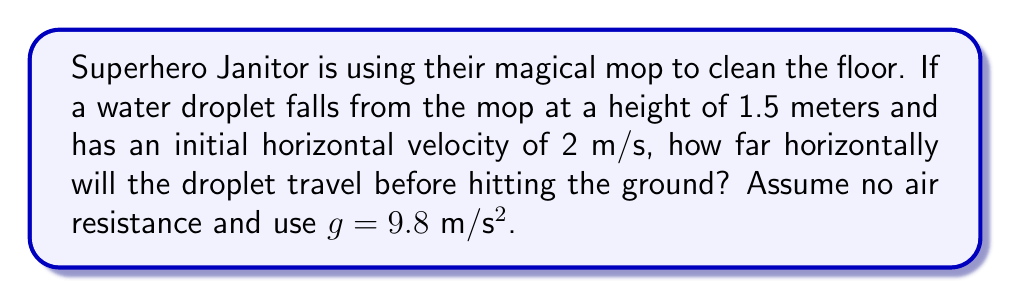Can you answer this question? Let's approach this step-by-step:

1) We can use the equations of motion for projectile motion. The horizontal and vertical motions are independent of each other.

2) For the vertical motion:
   Initial velocity (y-direction): $v_y = 0$ m/s
   Displacement (y-direction): $y = -1.5$ m (negative because it's falling)
   Acceleration: $a = g = 9.8$ m/s²

3) We can use the equation: $y = y_0 + v_0t + \frac{1}{2}at^2$
   
   $-1.5 = 0 + 0 + \frac{1}{2}(9.8)t^2$

4) Solving for t:
   $-1.5 = 4.9t^2$
   $t^2 = \frac{1.5}{4.9} = 0.3061$
   $t = \sqrt{0.3061} = 0.5533$ seconds

5) Now that we know the time, we can calculate the horizontal distance. For horizontal motion:
   Initial velocity (x-direction): $v_x = 2$ m/s
   Time: $t = 0.5533$ s
   Acceleration (x-direction): $a_x = 0$ (no acceleration in x-direction)

6) We can use the equation: $x = x_0 + v_xt$
   
   $x = 0 + 2(0.5533) = 1.1066$ meters

Therefore, the water droplet will travel approximately 1.11 meters horizontally before hitting the ground.
Answer: 1.11 m 